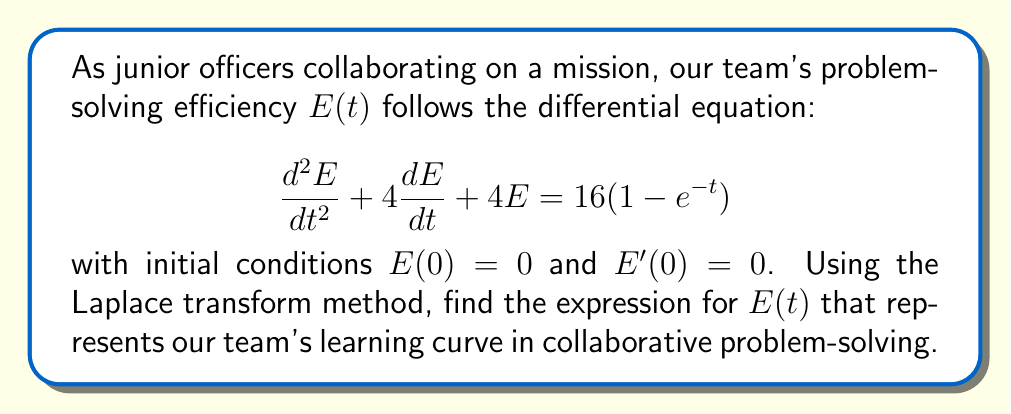Show me your answer to this math problem. 1) Let's apply the Laplace transform to both sides of the equation:
   $$\mathcal{L}\{E''(t) + 4E'(t) + 4E(t)\} = \mathcal{L}\{16(1-e^{-t})\}$$

2) Using Laplace transform properties:
   $$[s^2\mathcal{L}\{E(t)\} - sE(0) - E'(0)] + 4[s\mathcal{L}\{E(t)\} - E(0)] + 4\mathcal{L}\{E(t)\} = 16[\frac{1}{s} - \frac{1}{s+1}]$$

3) Substitute initial conditions $E(0) = 0$ and $E'(0) = 0$:
   $$s^2\mathcal{L}\{E(t)\} + 4s\mathcal{L}\{E(t)\} + 4\mathcal{L}\{E(t)\} = \frac{16}{s} - \frac{16}{s+1}$$

4) Factoring out $\mathcal{L}\{E(t)\}$:
   $$\mathcal{L}\{E(t)\}(s^2 + 4s + 4) = \frac{16}{s} - \frac{16}{s+1}$$

5) Solving for $\mathcal{L}\{E(t)\}$:
   $$\mathcal{L}\{E(t)\} = \frac{16}{s(s^2 + 4s + 4)} - \frac{16}{(s+1)(s^2 + 4s + 4)}$$

6) Decompose into partial fractions:
   $$\mathcal{L}\{E(t)\} = \frac{4}{s} - \frac{4}{s+2} - \frac{4}{s+1}$$

7) Apply inverse Laplace transform:
   $$E(t) = 4 - 4e^{-2t} - 4e^{-t}$$

This expression represents the learning curve of our collaborative problem-solving efficiency over time.
Answer: $E(t) = 4 - 4e^{-2t} - 4e^{-t}$ 